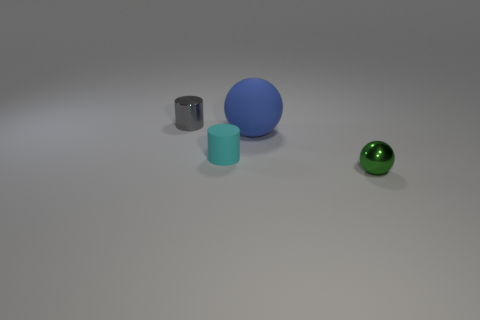Subtract all blue balls. How many balls are left? 1 Subtract 1 spheres. How many spheres are left? 1 Add 1 tiny gray metal cylinders. How many objects exist? 5 Subtract 0 gray spheres. How many objects are left? 4 Subtract all brown cylinders. Subtract all blue spheres. How many cylinders are left? 2 Subtract all blue balls. Subtract all blue matte balls. How many objects are left? 2 Add 4 gray cylinders. How many gray cylinders are left? 5 Add 3 blue matte cubes. How many blue matte cubes exist? 3 